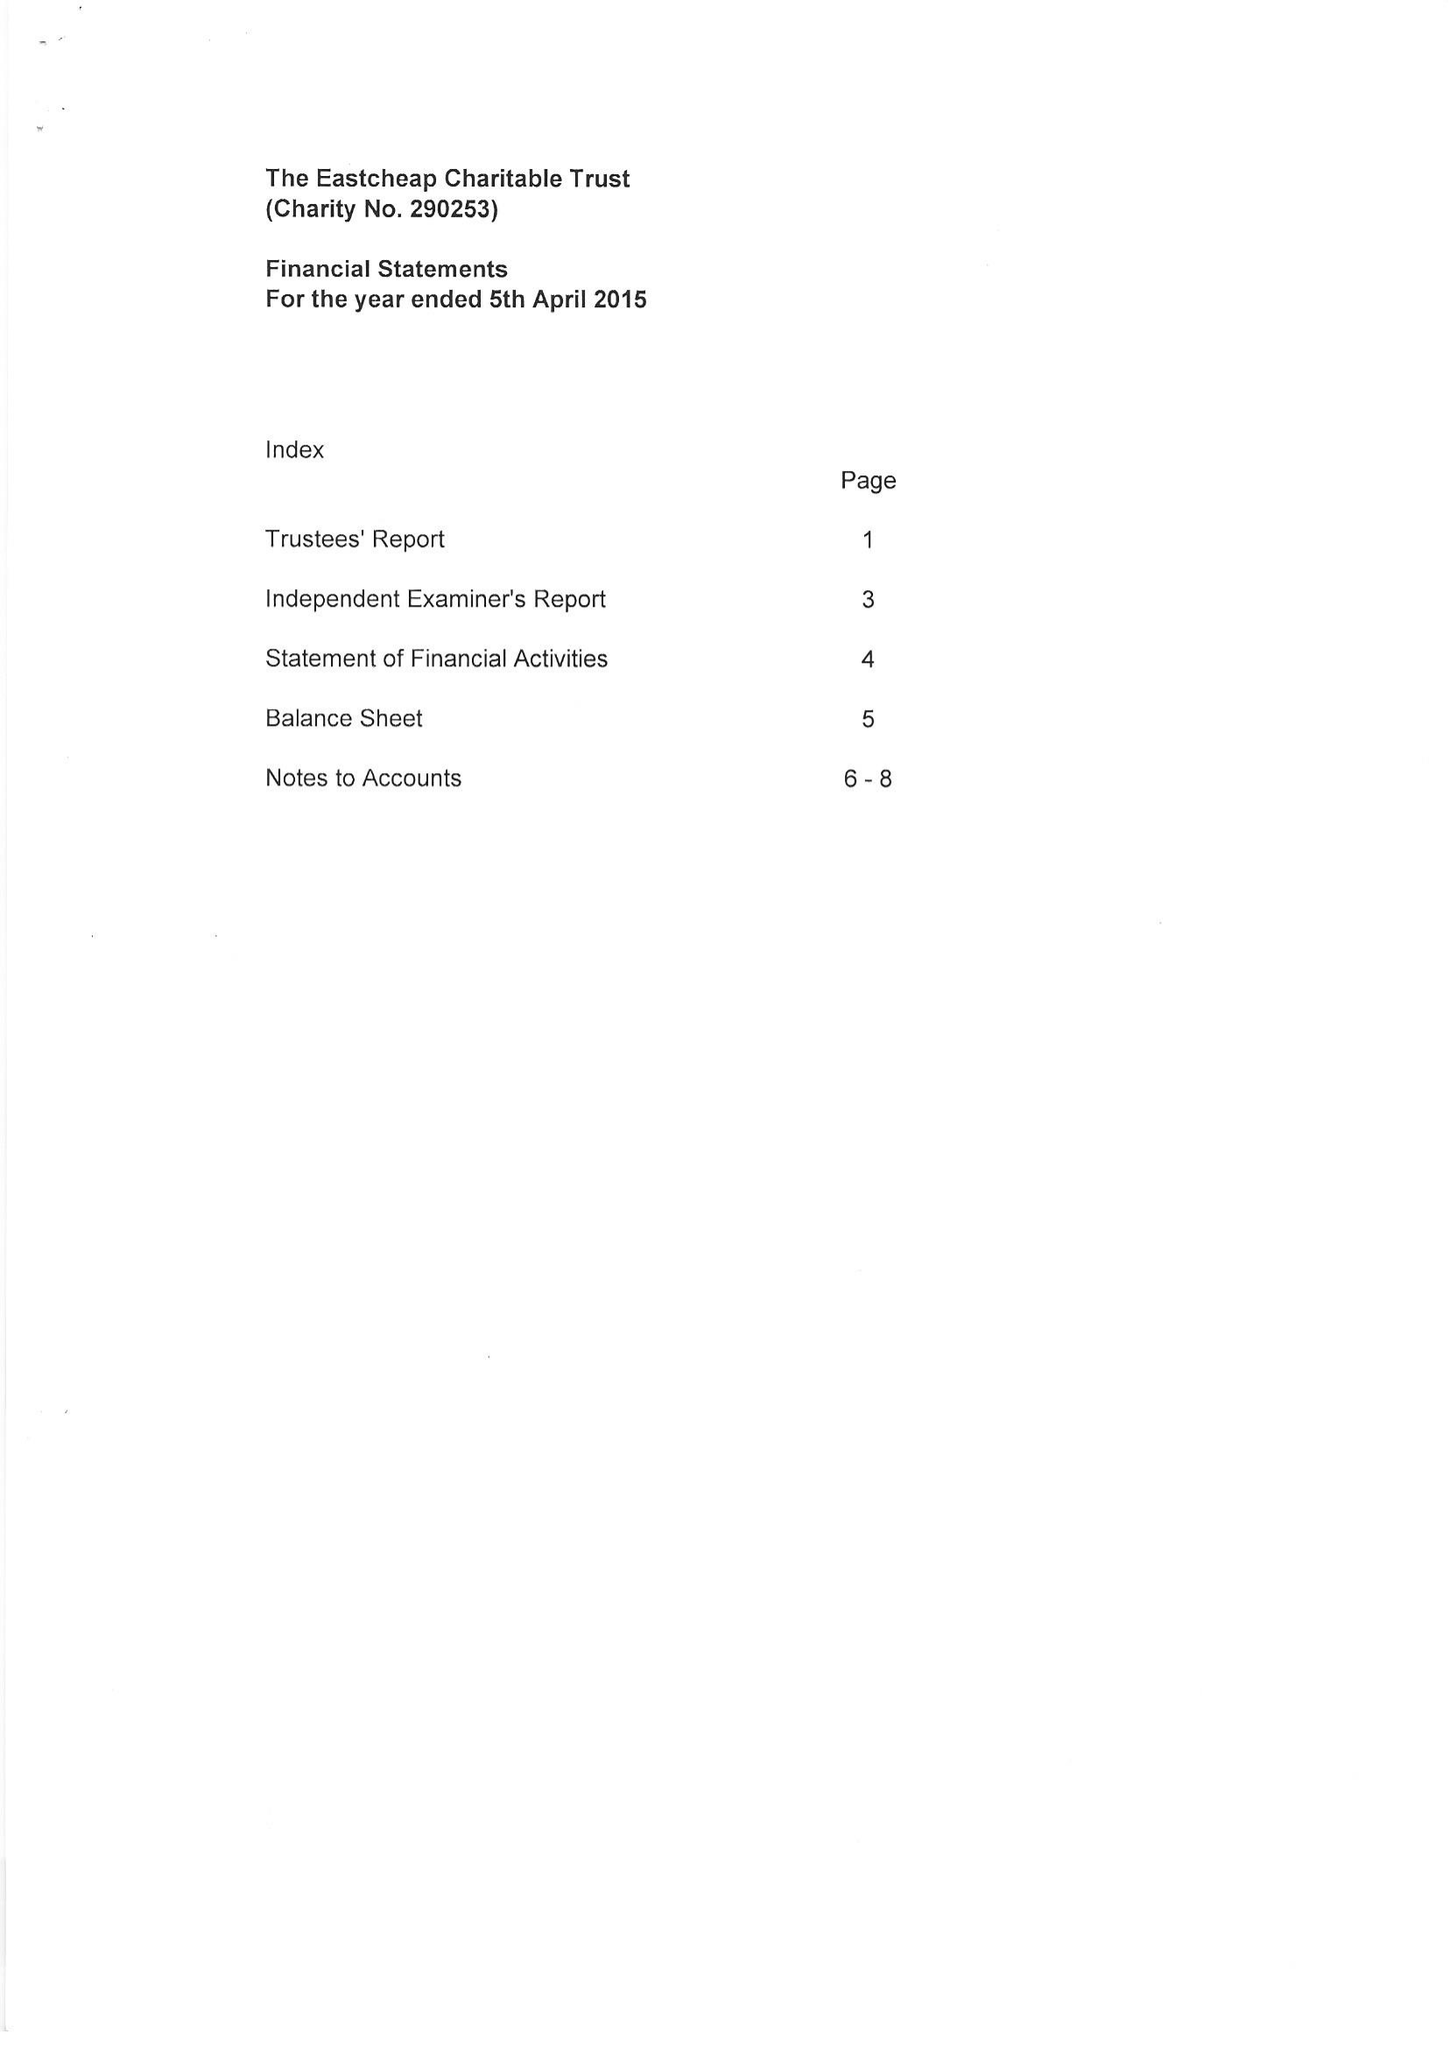What is the value for the income_annually_in_british_pounds?
Answer the question using a single word or phrase. 58946.00 